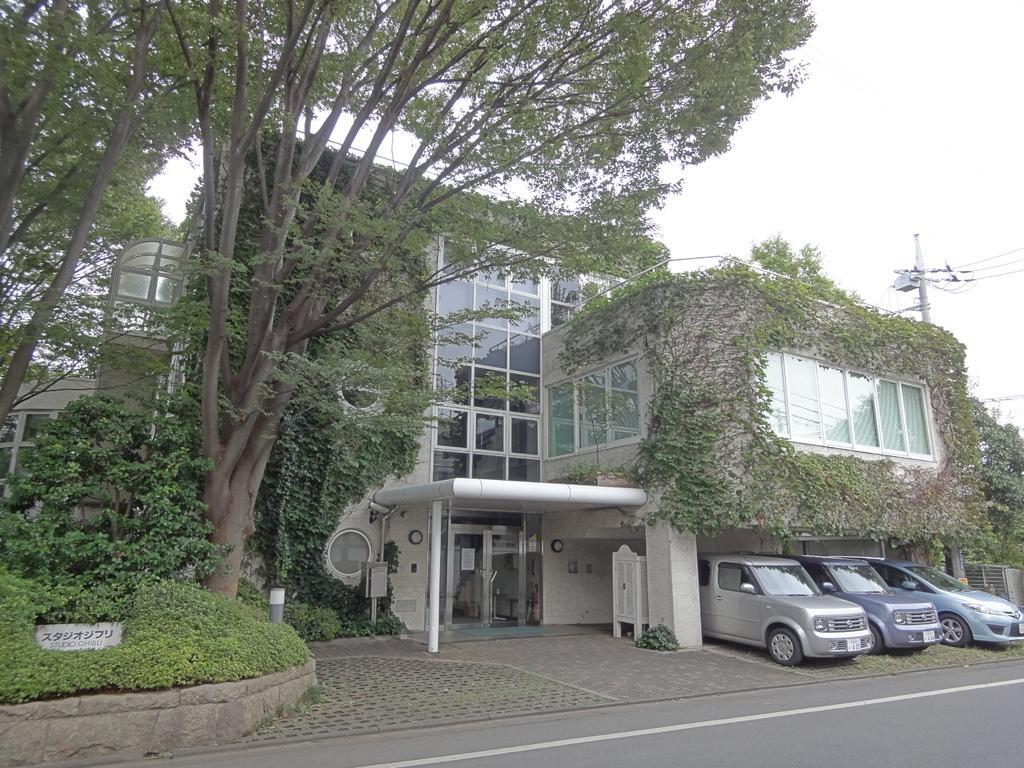Please provide a concise description of this image. In this picture there is a building and there are trees and there are vehicles. On the left side of the image there is a text on the stone. On the right side of the image there is a pole and there are wires on the pole. At the top there is sky. At the bottom there is a road. 